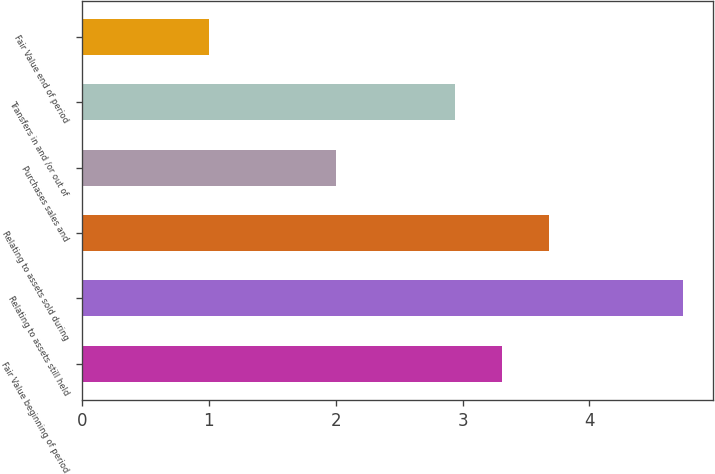<chart> <loc_0><loc_0><loc_500><loc_500><bar_chart><fcel>Fair Value beginning of period<fcel>Relating to assets still held<fcel>Relating to assets sold during<fcel>Purchases sales and<fcel>Transfers in and /or out of<fcel>Fair Value end of period<nl><fcel>3.31<fcel>4.74<fcel>3.68<fcel>2<fcel>2.94<fcel>1<nl></chart> 